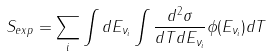<formula> <loc_0><loc_0><loc_500><loc_500>S _ { e x p } = \sum _ { i } \int d E _ { \nu _ { i } } \int \frac { d ^ { 2 } \sigma } { d T d E _ { \nu _ { i } } } \phi ( E _ { \nu _ { i } } ) d T</formula> 